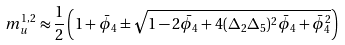<formula> <loc_0><loc_0><loc_500><loc_500>m _ { u } ^ { 1 , 2 } \approx \frac { 1 } { 2 } \left ( 1 + { \bar { \phi } } _ { 4 } \pm \sqrt { 1 - 2 { \bar { \phi } } _ { 4 } + 4 ( \Delta _ { 2 } \Delta _ { 5 } ) ^ { 2 } { \bar { \phi } } _ { 4 } + { \bar { \phi } } _ { 4 } ^ { 2 } } \right )</formula> 